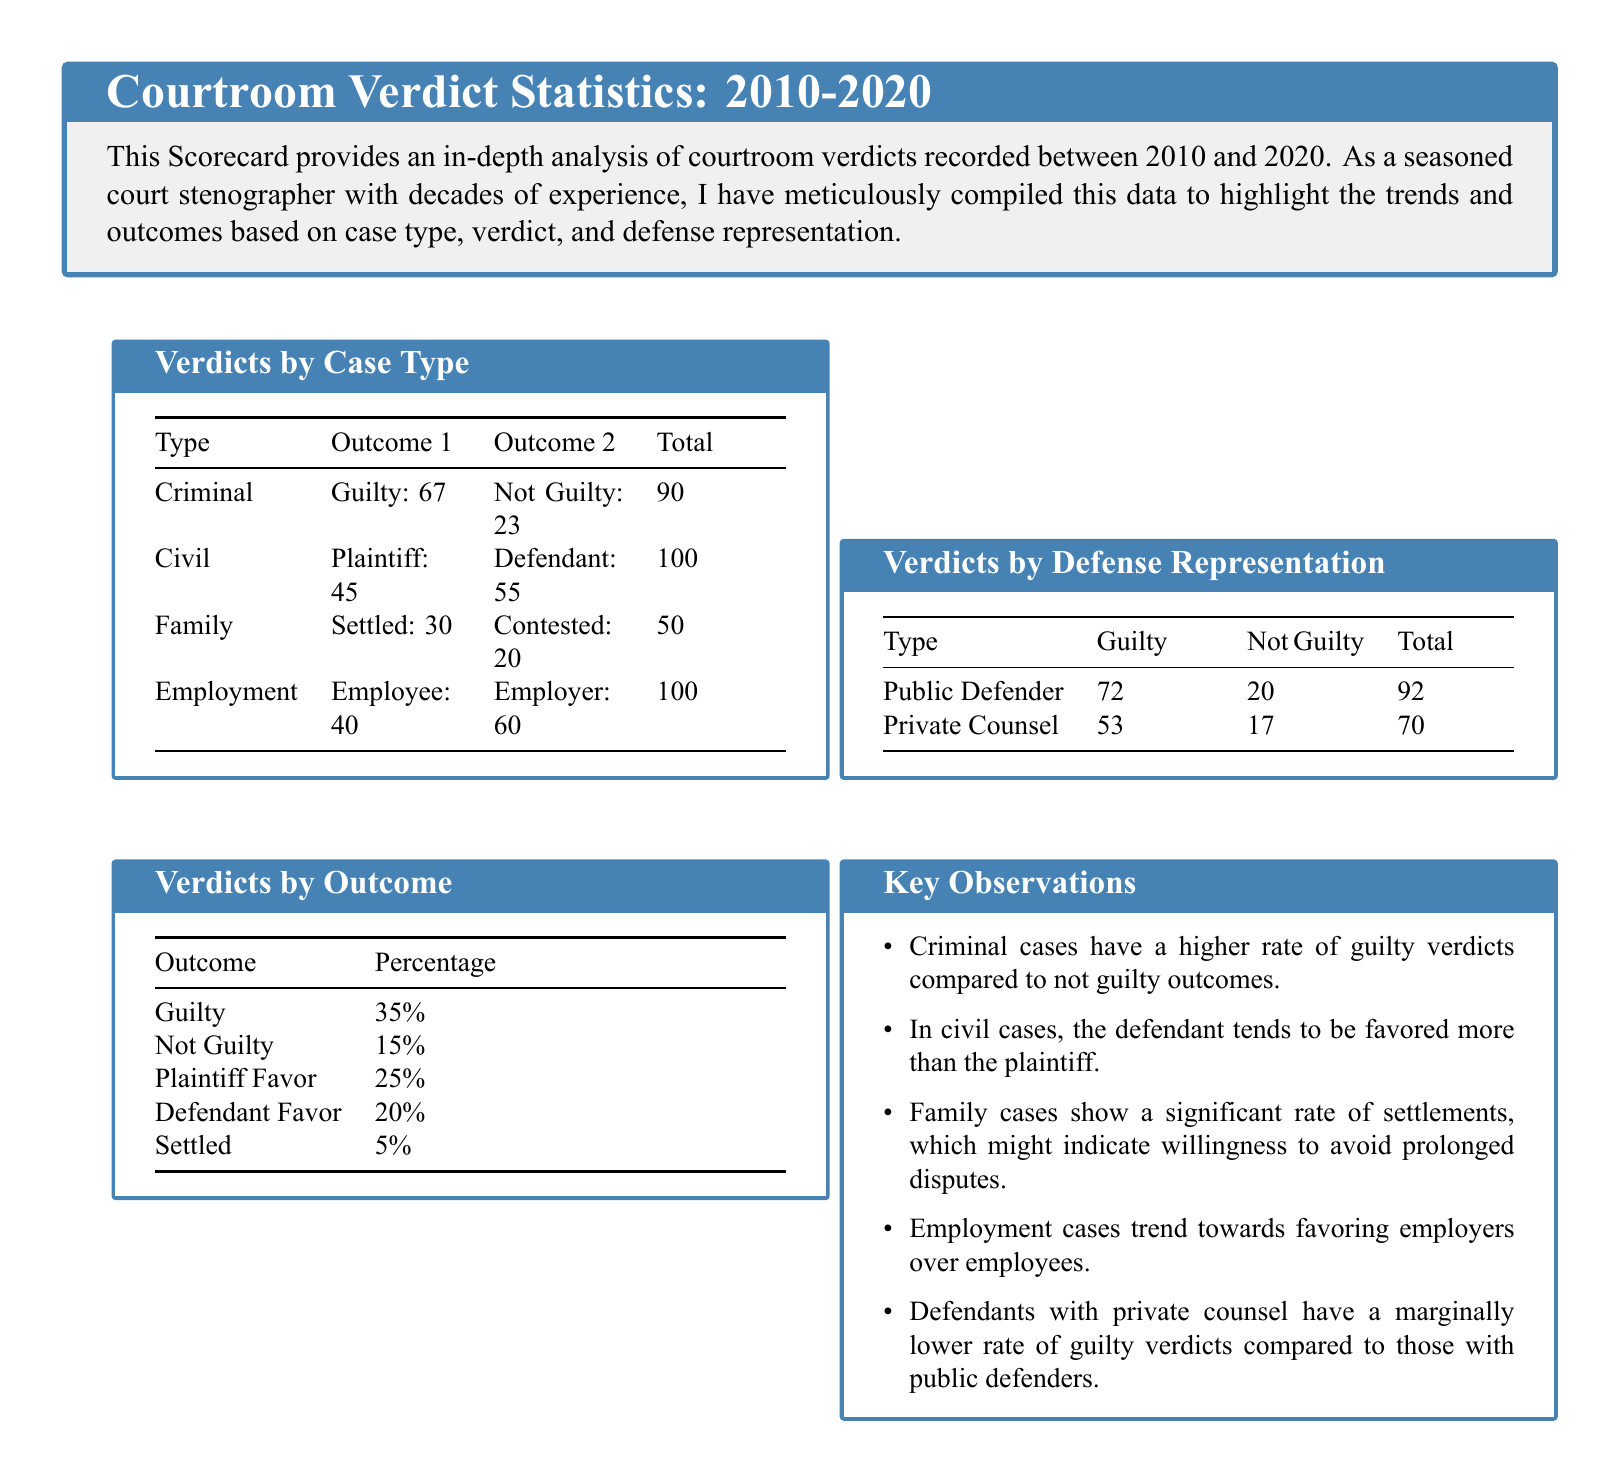What is the total number of criminal verdicts recorded? The total number of criminal verdicts is listed under "Total" in the "Verdicts by Case Type" section, which states there are 90.
Answer: 90 What percentage of outcomes resulted in a not guilty verdict? The percentage of not guilty outcomes is provided in the "Verdicts by Outcome" section, which shows 15%.
Answer: 15% Which case type has the highest total verdicts? The case type with the highest total verdicts can be determined by comparing the totals listed in "Verdicts by Case Type", which indicates Civil with 100.
Answer: Civil How many guilty verdicts were recorded with private counsel? The number of guilty verdicts with private counsel is indicated in the "Verdicts by Defense Representation" section, which shows 53.
Answer: 53 What outcome is favored more in civil cases? The favored outcome in civil cases is given by comparing the plaintiff and defendant outcomes in the "Verdicts by Case Type", showing the defendant is favored with 55.
Answer: Defendant What is the total number of family cases recorded? The total number of family cases is visible under "Total" in the "Verdicts by Case Type", which states there are 50.
Answer: 50 What is the ratio of guilty verdicts to not guilty verdicts for public defenders? The ratio can be calculated from the values in the "Verdicts by Defense Representation", which shows 72 guilty and 20 not guilty, giving a ratio of 72:20.
Answer: 72:20 What percentage of cases resulted in a settlement in family cases? The percentage of settlements in family cases is derived from "Settled" cases over total family cases (30 out of 50), yielding 60%.
Answer: 60% Which case type shows a significant number of settlements? The case type with a significant number of settlements is identified in the "Key Observations", which mentions Family cases.
Answer: Family 